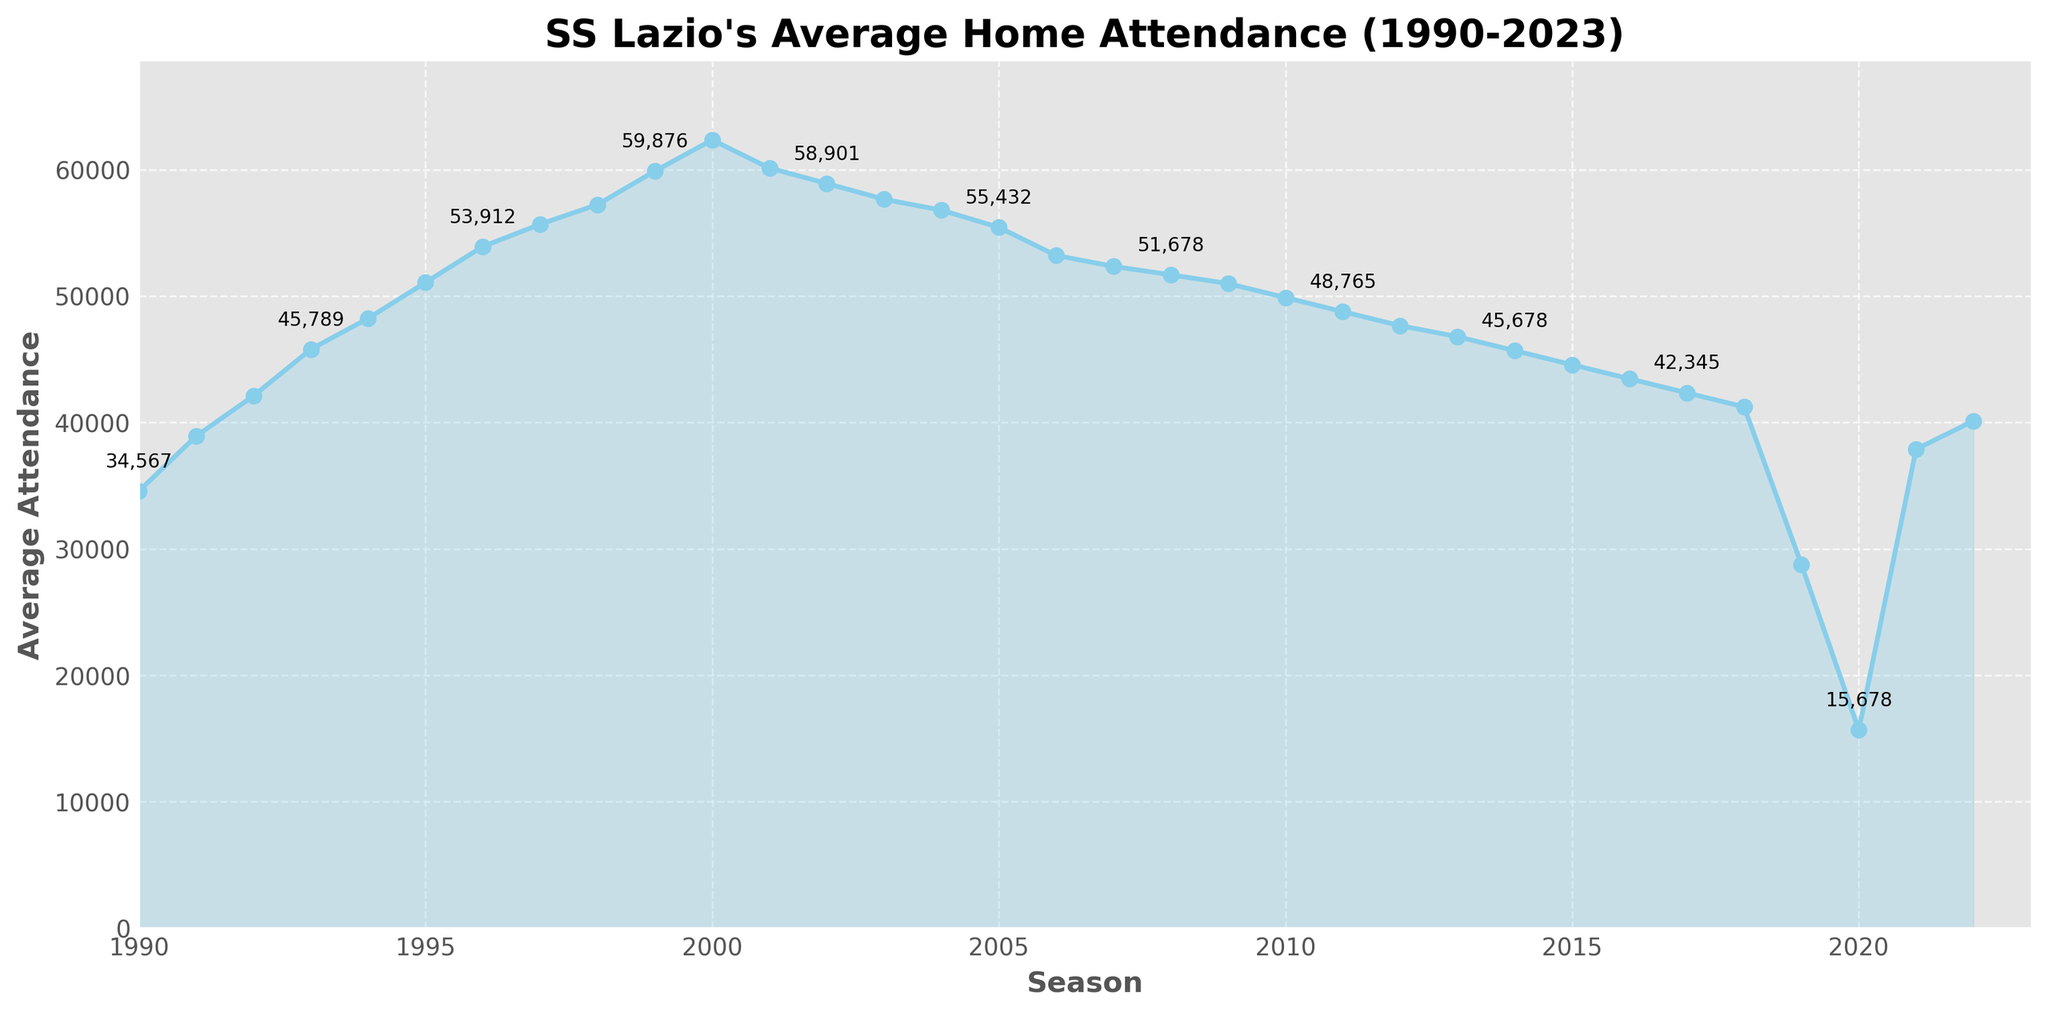What was the highest average home attendance for SS Lazio during the period from 1990-2023? The highest point on the line chart represents the highest average home attendance. The peak occurs in the 2000-01 season with an attendance of 62,345.
Answer: 62,345 How did the average attendance change from the 2000-01 season to the 2001-02 season? To find the change, we subtract the 2001-02 attendance (60,123) from the 2000-01 attendance (62,345). The difference is 62,345 - 60,123 = 2,222.
Answer: Decreased by 2,222 How does the average attendance in 2022-23 compare to the attendance in 2019-20? We look at the two points on the line chart: 40,123 (2022-23) and 28,765 (2019-20). 40,123 is greater than 28,765, indicating an increase.
Answer: Increased What was the average attendance trend from 2016-17 to 2018-19? The points on the line chart show a decreasing trend: 43,456 (2016-17), 42,345 (2017-18), and 41,234 (2018-19). This indicates a consistent decline over these seasons.
Answer: Decreasing Between which consecutive seasons did SS Lazio experience the largest drop in average attendance? By observing the largest drop on the chart, from 2019-20 (28,765) to 2020-21 (15,678) represents the largest decrease. The difference is 28,765 - 15,678 = 13,087.
Answer: 2019-20 to 2020-21 What was the difference in average attendance between the 1996-97 season and the 1999-00 season? The attendance for 1996-97 was 53,912 and for 1999-00 was 59,876. The difference is 59,876 - 53,912 = 5,964.
Answer: 5,964 How did the average attendance from the 2005-06 season to the 2008-09 season change arithmetic-mean-wise? The attendances are 55,432 (05-06), 53,210 (06-07), 52,345 (07-08), and 51,678 (08-09). Their average is (55,432 + 53,210 + 52,345 + 51,678) / 4 = 53,166.25.
Answer: 53,166.25 Did SS Lazio’s average attendance in the 2021-22 season surpass the average attendance in the 2018-19 season? The 2021-22 attendance was 37,890 compared to 41,234 in 2018-19. Since 37,890 is less than 41,234, it did not surpass.
Answer: No When did SS Lazio experience a steady decline in average attendance over consecutive seasons between 2010 and 2015? The data points from 2010-11 (49,876) to 2014-15 (45,678) consistently decrease.
Answer: 2010-11 to 2014-15 